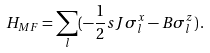<formula> <loc_0><loc_0><loc_500><loc_500>H _ { M F } = \sum _ { l } ( - \frac { 1 } { 2 } s J \sigma _ { l } ^ { x } - B \sigma _ { l } ^ { z } ) \, .</formula> 